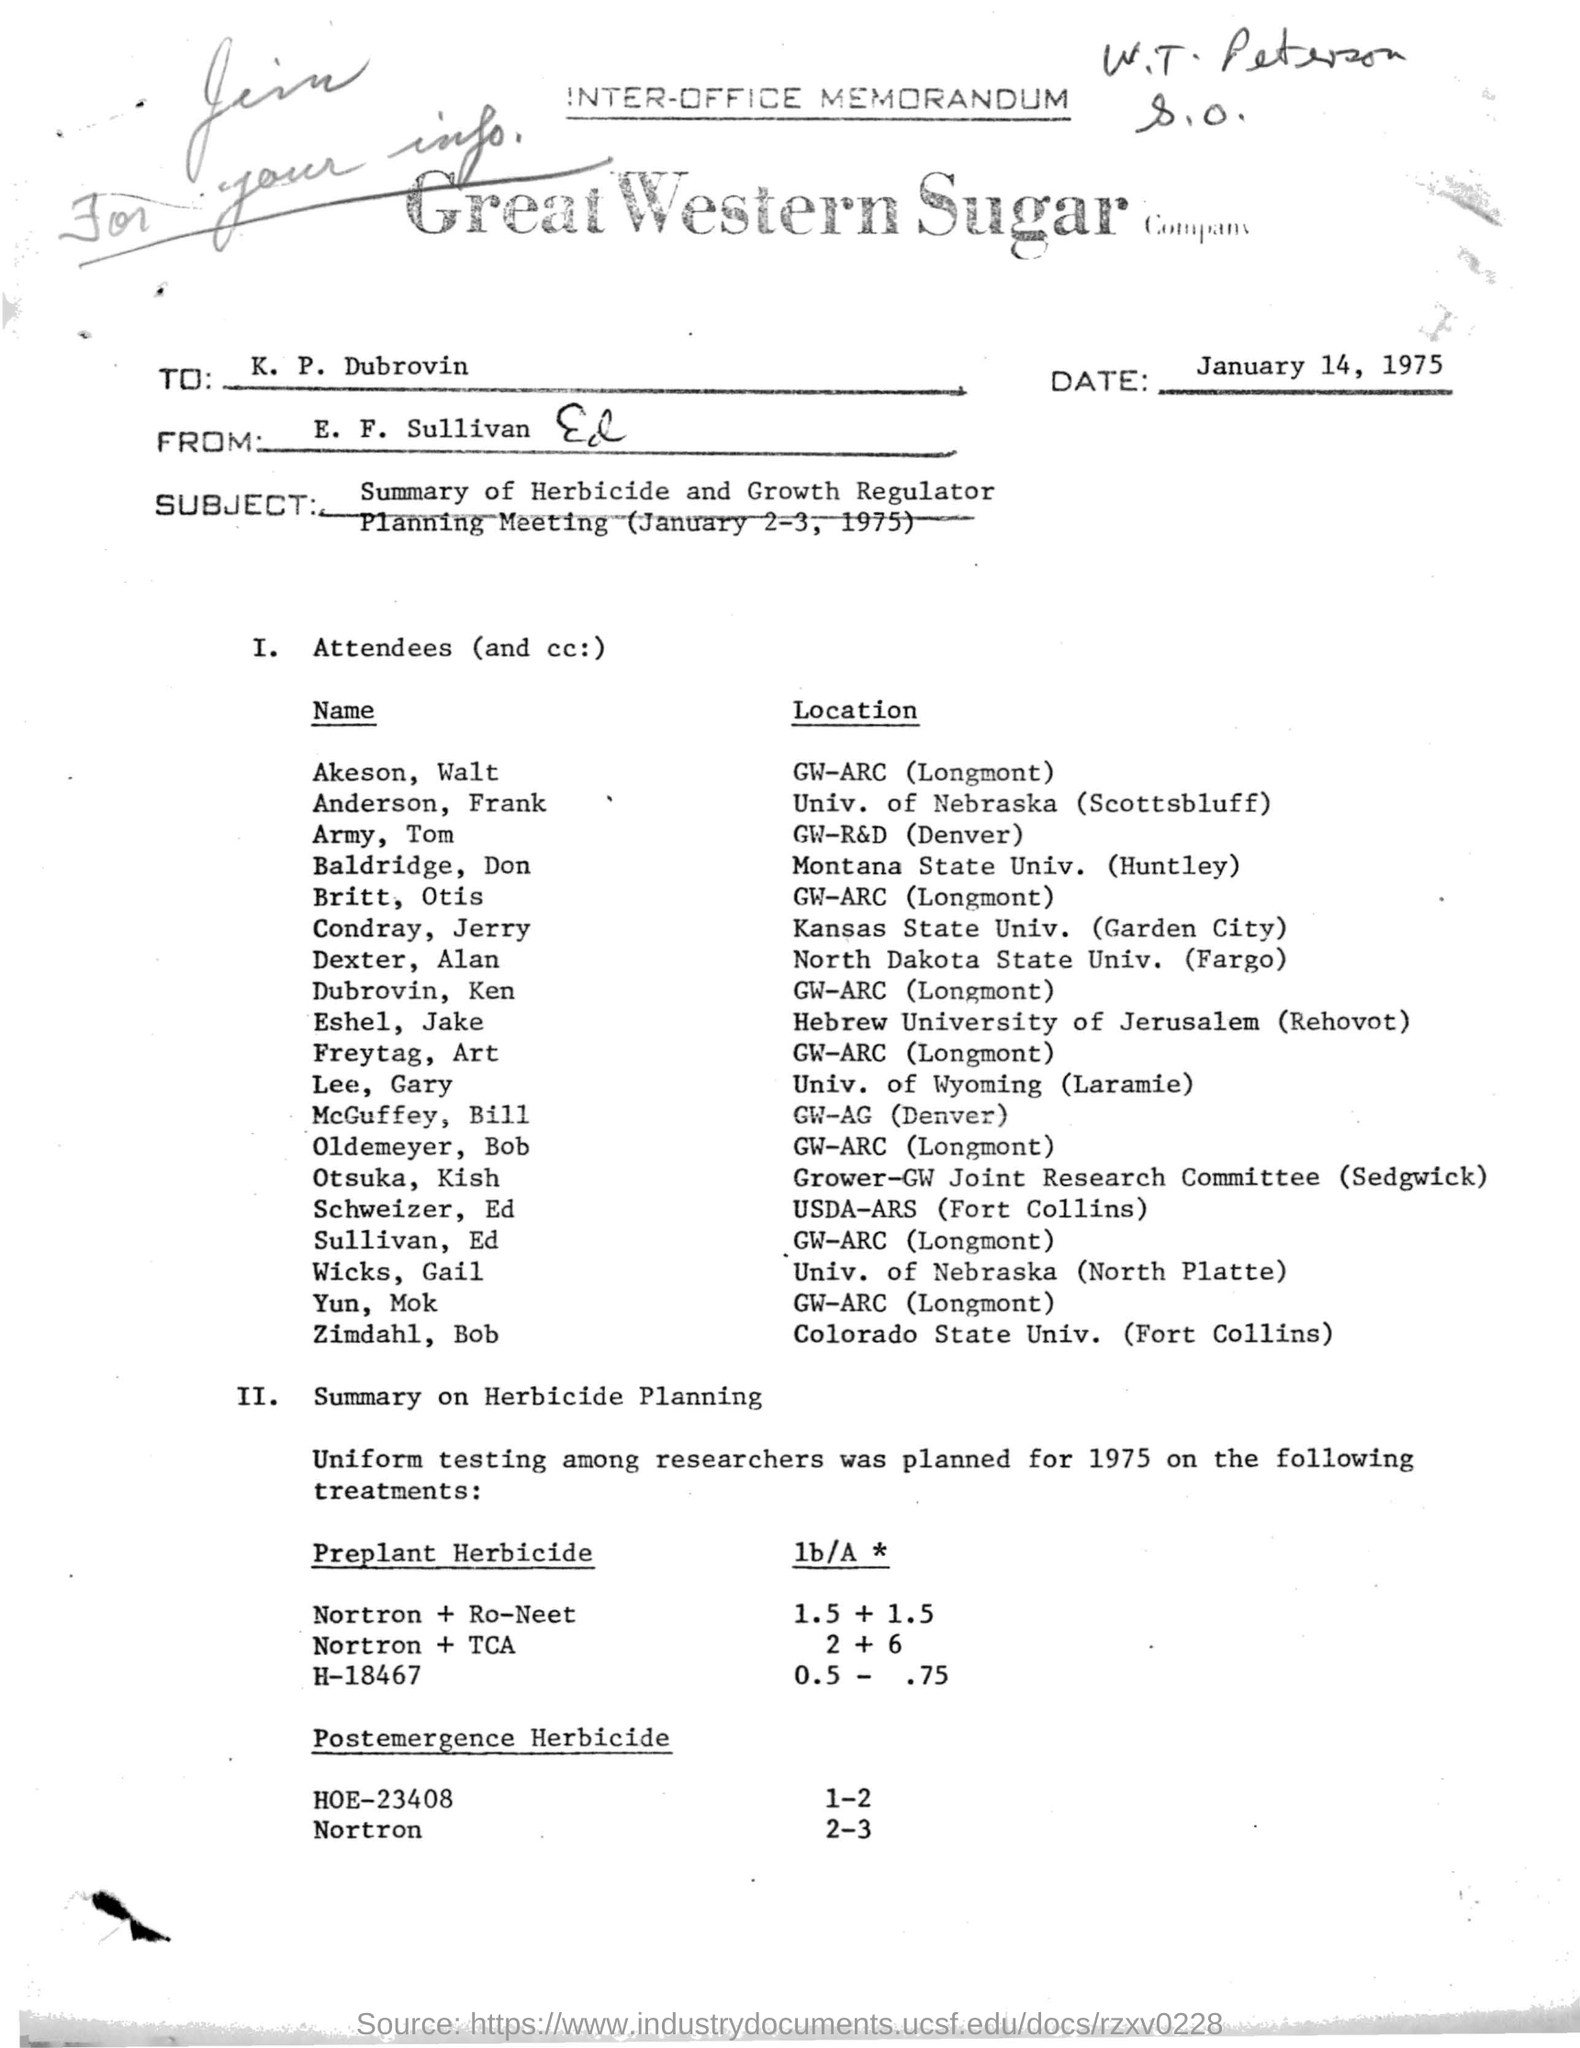Point out several critical features in this image. The document at the top of the page bears the title 'INTER-OFFICE MEMORANDUM.' The date mentioned at the top of the document is January 14, 1975. The planning of uniform testing among researches was initiated in the year 1975. The location of Akeson, Walt is GW-ARC in Longmont. The sender is E. F. Sullivan. 